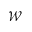<formula> <loc_0><loc_0><loc_500><loc_500>\mathcal { W }</formula> 